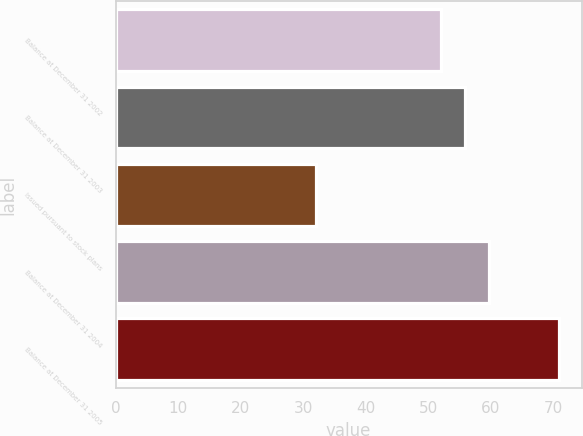<chart> <loc_0><loc_0><loc_500><loc_500><bar_chart><fcel>Balance at December 31 2002<fcel>Balance at December 31 2003<fcel>Issued pursuant to stock plans<fcel>Balance at December 31 2004<fcel>Balance at December 31 2005<nl><fcel>52<fcel>55.9<fcel>32<fcel>59.8<fcel>71<nl></chart> 